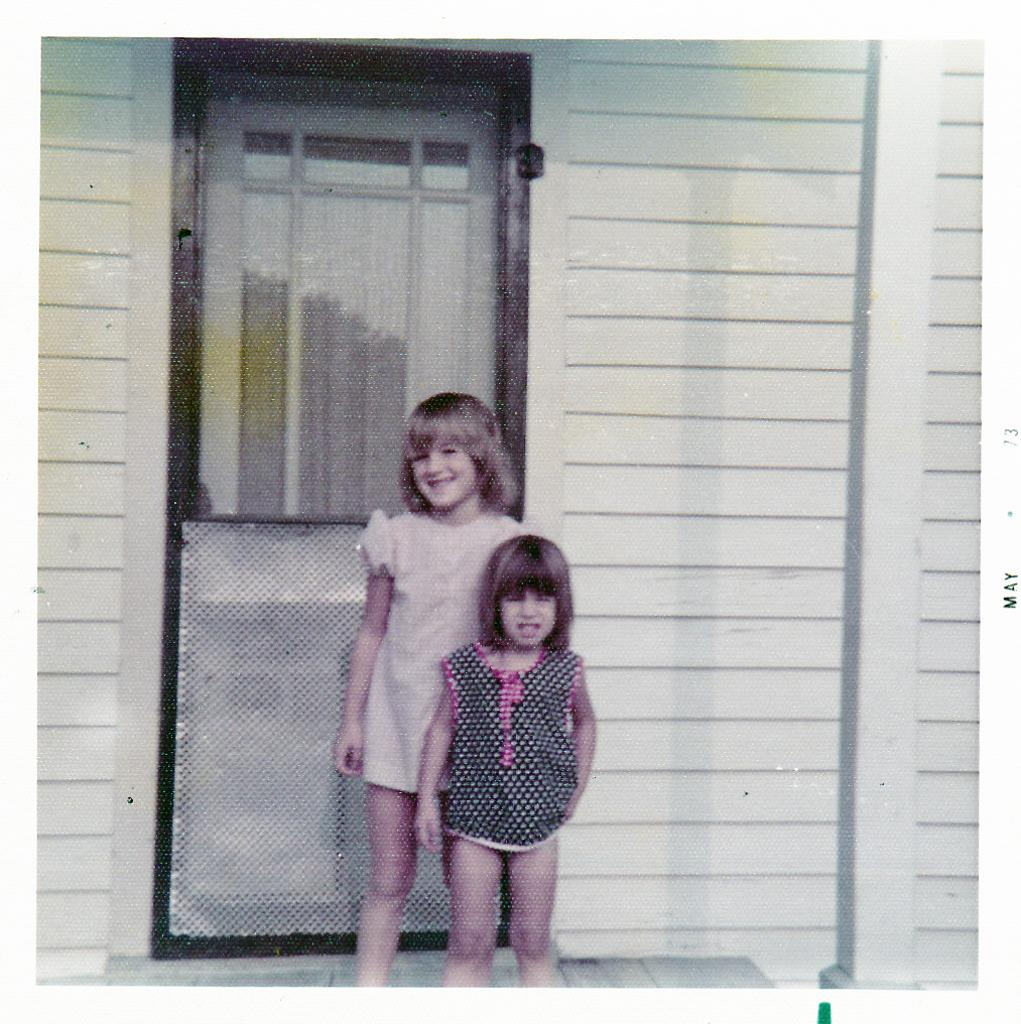How many kids are in the image? There are two kids standing in front of the image. What is behind the kids? There is a closed door behind the kids. What can be seen on the sides of the image? There is a wall visible in the image, and there is a pillar on the right side of the image. What type of wine is being served on the bone in the image? There is no wine or bone present in the image. 